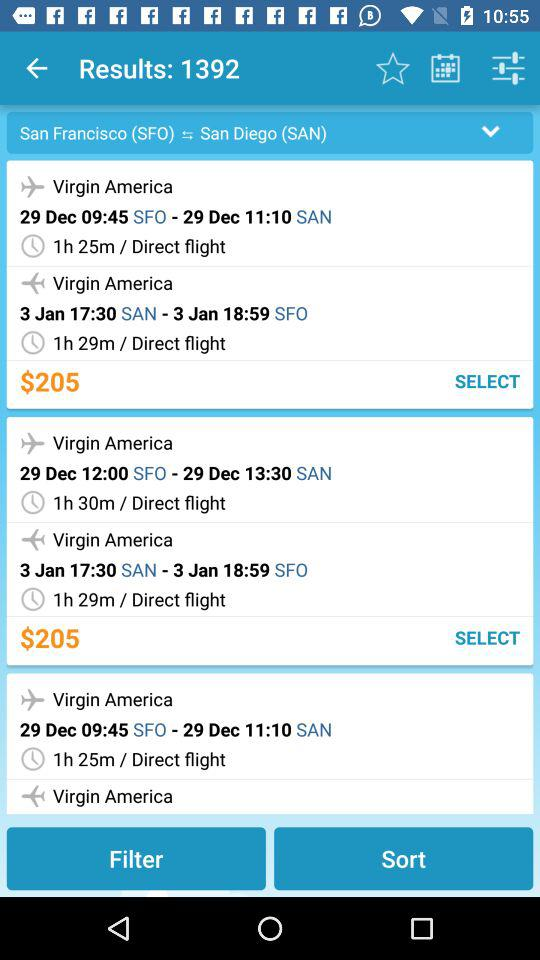What is the total price of the flight ticket? The total price is $205. 